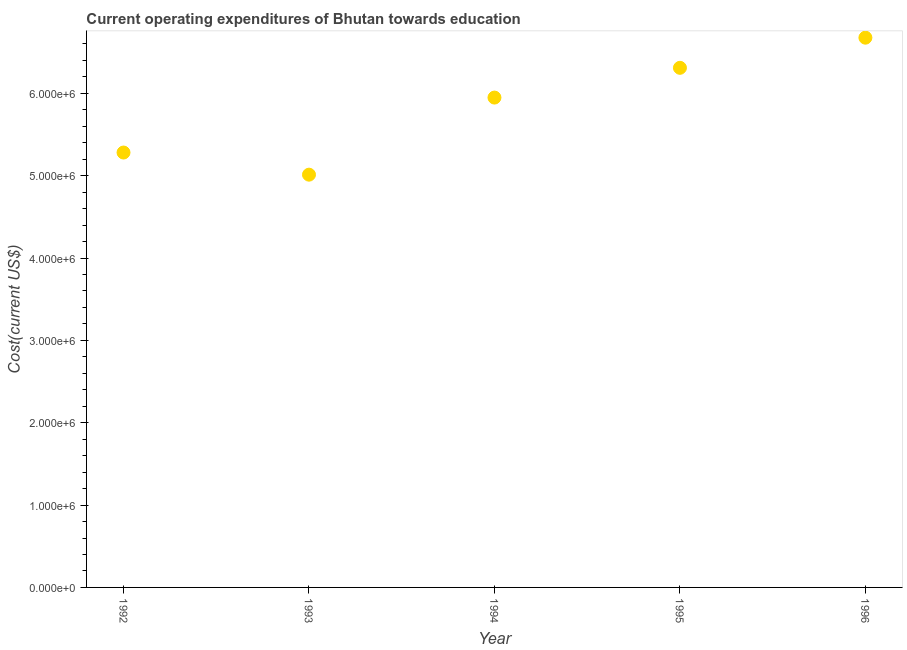What is the education expenditure in 1993?
Make the answer very short. 5.01e+06. Across all years, what is the maximum education expenditure?
Your answer should be compact. 6.68e+06. Across all years, what is the minimum education expenditure?
Your response must be concise. 5.01e+06. In which year was the education expenditure minimum?
Keep it short and to the point. 1993. What is the sum of the education expenditure?
Your response must be concise. 2.92e+07. What is the difference between the education expenditure in 1992 and 1994?
Make the answer very short. -6.67e+05. What is the average education expenditure per year?
Give a very brief answer. 5.85e+06. What is the median education expenditure?
Offer a terse response. 5.95e+06. In how many years, is the education expenditure greater than 3000000 US$?
Your response must be concise. 5. Do a majority of the years between 1993 and 1996 (inclusive) have education expenditure greater than 4200000 US$?
Offer a terse response. Yes. What is the ratio of the education expenditure in 1992 to that in 1996?
Ensure brevity in your answer.  0.79. Is the difference between the education expenditure in 1992 and 1994 greater than the difference between any two years?
Your answer should be very brief. No. What is the difference between the highest and the second highest education expenditure?
Make the answer very short. 3.66e+05. What is the difference between the highest and the lowest education expenditure?
Make the answer very short. 1.66e+06. Does the education expenditure monotonically increase over the years?
Provide a succinct answer. No. How many years are there in the graph?
Keep it short and to the point. 5. Does the graph contain any zero values?
Provide a succinct answer. No. What is the title of the graph?
Offer a terse response. Current operating expenditures of Bhutan towards education. What is the label or title of the Y-axis?
Your response must be concise. Cost(current US$). What is the Cost(current US$) in 1992?
Give a very brief answer. 5.28e+06. What is the Cost(current US$) in 1993?
Your answer should be compact. 5.01e+06. What is the Cost(current US$) in 1994?
Offer a very short reply. 5.95e+06. What is the Cost(current US$) in 1995?
Offer a terse response. 6.31e+06. What is the Cost(current US$) in 1996?
Provide a short and direct response. 6.68e+06. What is the difference between the Cost(current US$) in 1992 and 1993?
Your answer should be very brief. 2.69e+05. What is the difference between the Cost(current US$) in 1992 and 1994?
Keep it short and to the point. -6.67e+05. What is the difference between the Cost(current US$) in 1992 and 1995?
Make the answer very short. -1.03e+06. What is the difference between the Cost(current US$) in 1992 and 1996?
Your response must be concise. -1.39e+06. What is the difference between the Cost(current US$) in 1993 and 1994?
Your answer should be compact. -9.36e+05. What is the difference between the Cost(current US$) in 1993 and 1995?
Keep it short and to the point. -1.30e+06. What is the difference between the Cost(current US$) in 1993 and 1996?
Give a very brief answer. -1.66e+06. What is the difference between the Cost(current US$) in 1994 and 1995?
Give a very brief answer. -3.61e+05. What is the difference between the Cost(current US$) in 1994 and 1996?
Provide a short and direct response. -7.28e+05. What is the difference between the Cost(current US$) in 1995 and 1996?
Your response must be concise. -3.66e+05. What is the ratio of the Cost(current US$) in 1992 to that in 1993?
Offer a very short reply. 1.05. What is the ratio of the Cost(current US$) in 1992 to that in 1994?
Offer a very short reply. 0.89. What is the ratio of the Cost(current US$) in 1992 to that in 1995?
Offer a terse response. 0.84. What is the ratio of the Cost(current US$) in 1992 to that in 1996?
Keep it short and to the point. 0.79. What is the ratio of the Cost(current US$) in 1993 to that in 1994?
Provide a succinct answer. 0.84. What is the ratio of the Cost(current US$) in 1993 to that in 1995?
Keep it short and to the point. 0.79. What is the ratio of the Cost(current US$) in 1993 to that in 1996?
Make the answer very short. 0.75. What is the ratio of the Cost(current US$) in 1994 to that in 1995?
Keep it short and to the point. 0.94. What is the ratio of the Cost(current US$) in 1994 to that in 1996?
Give a very brief answer. 0.89. What is the ratio of the Cost(current US$) in 1995 to that in 1996?
Offer a very short reply. 0.94. 